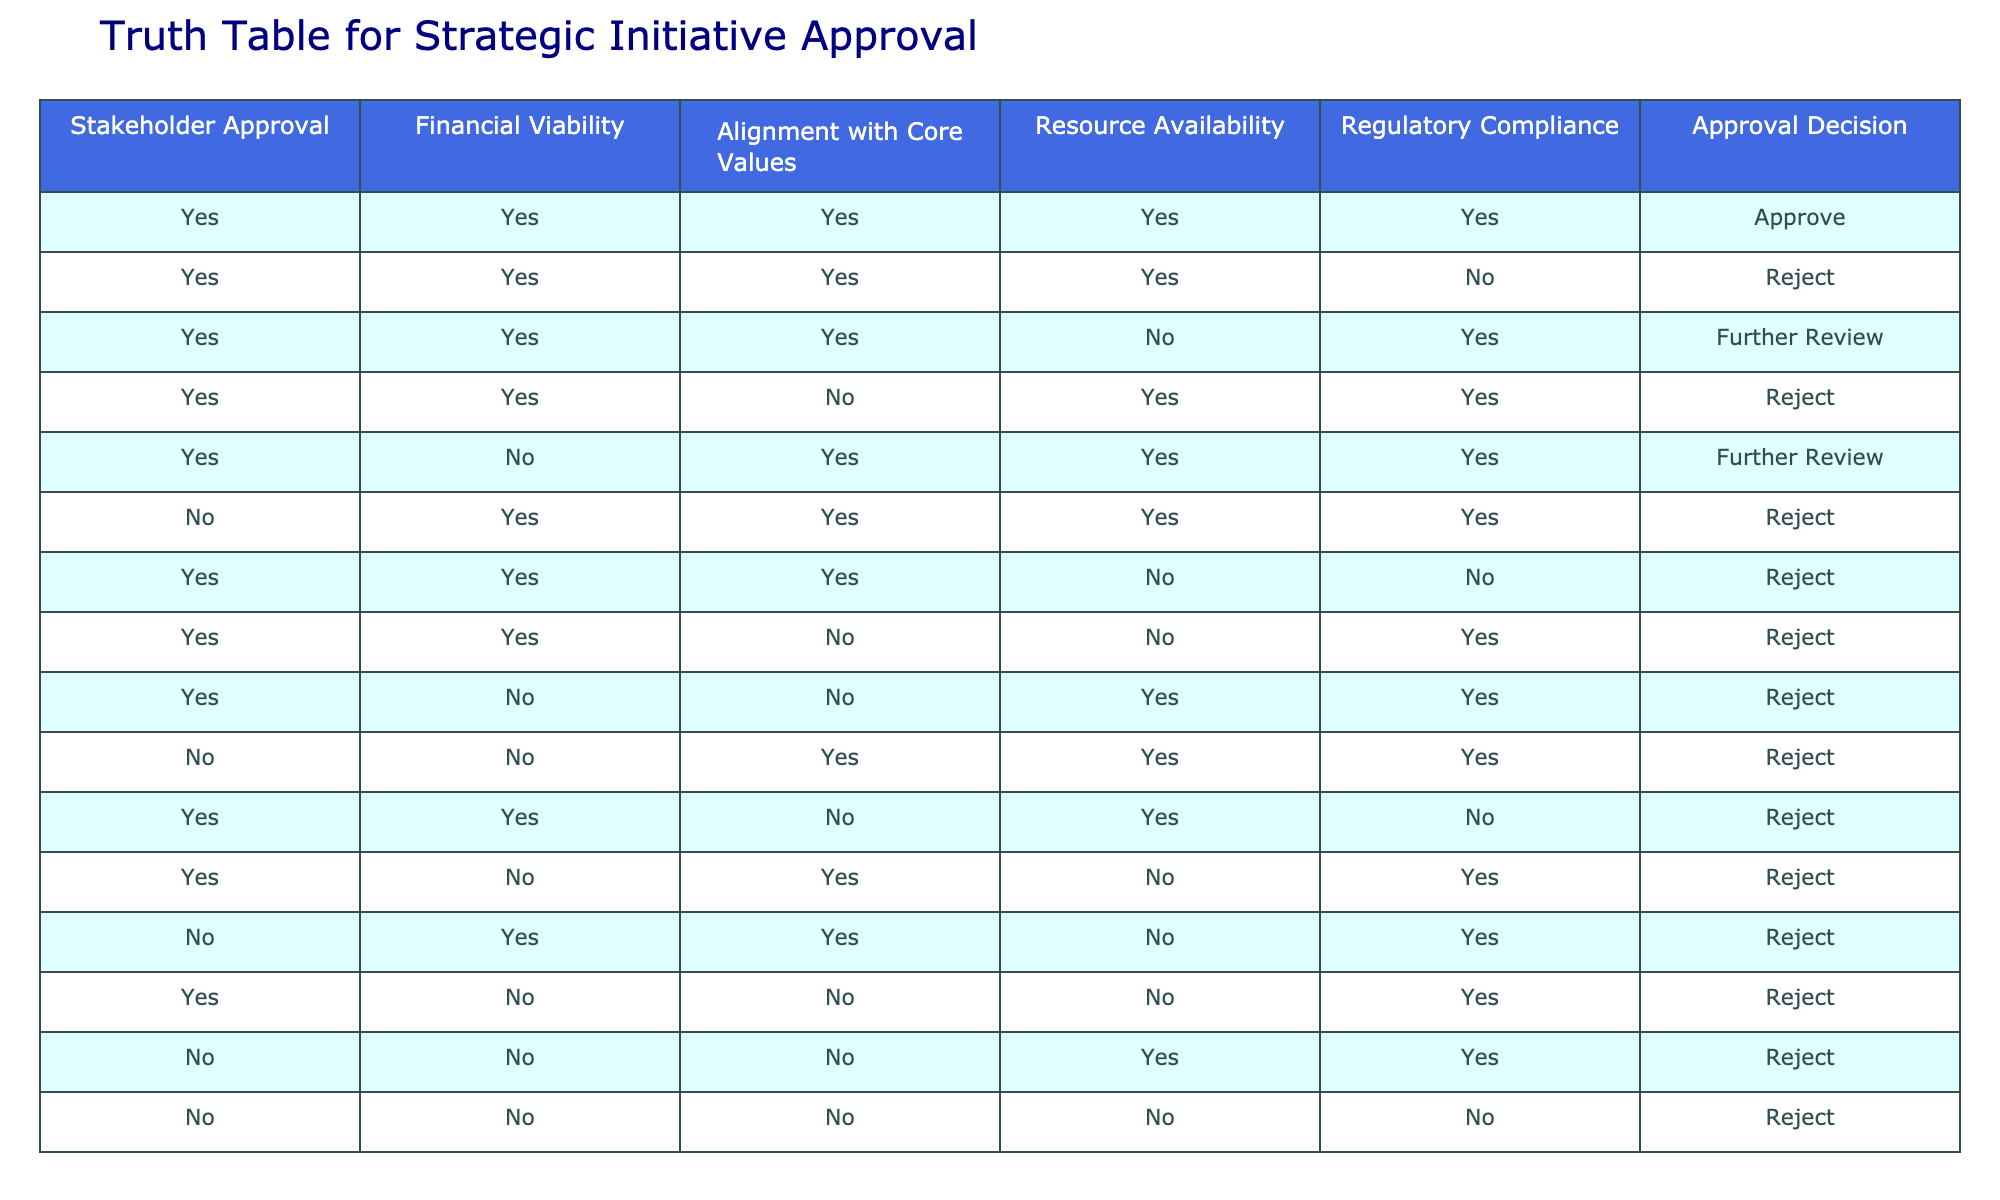What is the overall approval decision when all conditions are 'Yes'? In the table, when all conditions—Stakeholder Approval, Financial Viability, Alignment with Core Values, Resource Availability, and Regulatory Compliance—are 'Yes', the Approval Decision is 'Approve'. This can be found in the first row of the table.
Answer: Approve How many initiatives received a 'Further Review' decision? The table indicates that two scenarios lead to 'Further Review': the fifth row (where Resource Availability is 'No') and the second row (where Regulatory Compliance is 'No'). Therefore, there are 2 initiatives that received a 'Further Review' decision.
Answer: 2 Is there an initiative that was approved with a 'No' in Regulatory Compliance? By examining the table, no rows have a decision of 'Approve' where Regulatory Compliance is 'No'. The only instance of 'Approve' appears with 'Yes' in all categories.
Answer: No How many initiatives were rejected due to 'Financial Viability' being 'No'? Looking at the table, there are three scenarios where the Approval Decision is 'Reject' and 'Financial Viability' is 'No' (the rows containing 'No' in the second column). Summarizing the rows gives us specific counts, and the total is 5.
Answer: 5 What is the decision when both 'Stakeholder Approval' and 'Resource Availability' are 'Yes', but 'Regulatory Compliance' is 'No'? The table shows that the scenario with 'Stakeholder Approval' as 'Yes', 'Resource Availability' as 'Yes', and 'Regulatory Compliance' as 'No' leads to a decision of 'Reject'. This can be identified specifically in the seventh row.
Answer: Reject What percentage of initiatives were approved out of the total initiatives listed in the table? There is 1 'Approve' decision out of a total of 15 initiatives. To calculate the percentage, divide 1 by 15 and multiply by 100, which results in approximately 6.67 percent approval.
Answer: 6.67% Do all initiatives that have 'No' in 'Alignment with Core Values' lead to a rejection? By reviewing the table, all entries with 'Alignment with Core Values' marked as 'No' lead to a decision of 'Reject', confirming that this condition directly correlates to the rejection of strategic initiatives.
Answer: Yes How many total strategic initiatives are listed? The data shows 15 rows corresponding to the decisions made about strategic initiatives. This count includes every scenario listed in the table.
Answer: 15 Are there any initiatives that received a 'Further Review' decision with a 'No' in Stakeholder Approval? Analyzing the data, only initiatives with 'Stakeholder Approval' as 'Yes' lead to 'Further Review'; therefore, there are no cases where 'No' in Stakeholder Approval corresponds to a 'Further Review' decision.
Answer: No What is the majority decision in the table, and how many entries reflect that decision? The majority decision across all initiatives in the table is 'Reject', which appears a total of 12 times. By counting all rows and identifying the decisions leads to this conclusion, confirming rejection as the prevailing outcome.
Answer: Reject, 12 